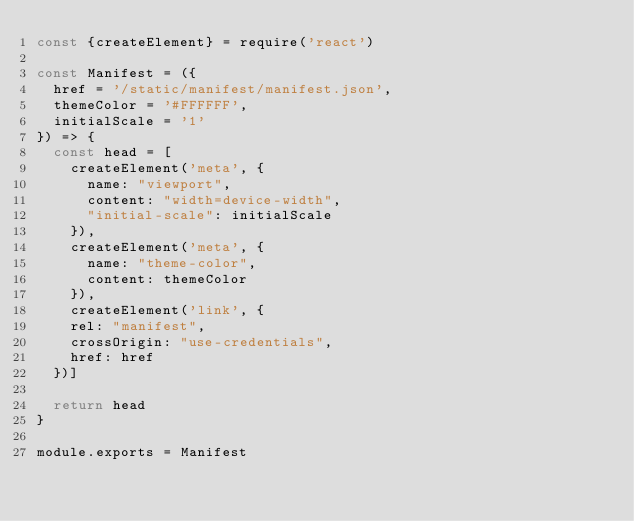Convert code to text. <code><loc_0><loc_0><loc_500><loc_500><_JavaScript_>const {createElement} = require('react')

const Manifest = ({
  href = '/static/manifest/manifest.json',
  themeColor = '#FFFFFF',
  initialScale = '1'
}) => {
  const head = [
    createElement('meta', {
      name: "viewport",
      content: "width=device-width",
      "initial-scale": initialScale
    }),
    createElement('meta', {
      name: "theme-color",
      content: themeColor
    }),
    createElement('link', {
    rel: "manifest",
    crossOrigin: "use-credentials",
    href: href
  })]

  return head
}

module.exports = Manifest
</code> 